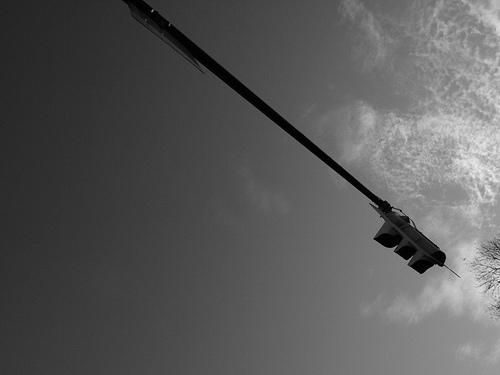Provide a brief description of the central object in the image and the overall atmosphere. A traffic light mounted on a pole is the central object, set in an outdoor cloudy daytime environment, captured in black and white. Explain the main focus of the image, including any significant details or accessories. The image primarily features a traffic light system and its pole, with noticeable details such as electrical wires and a sign attached to the pole. Mention the primary object of the image and its surrounding environment. A traffic light system is the central focus, accompanied by a tree with bare branches, clouds in the sky, and a street sign on a pole. Provide a concise description of the overall scene in the image. The scene comprises a traffic light and pole, a tree with bare branches, a sign on the pole, and white cloud formations against the sky. Highlight the most noticeable object in the image and mention its surroundings. A stoplight stands out in the image, with a tree without leaves on the right side and a mix of clear skies and white clouds in the background. Mention the standout element in the image and describe the secondary components in the scene. The image prominently features a traffic light, with accompanying elements such as bare tree branches, sign on the pole, and clouds in the sky. Provide a brief summary of the main elements in the image. The image features a stoplight on a pole, a tree without leaves, a sign attached to the pole, electrical wires, and clouds in the sky. Describe the primary subject in the picture, focusing on its surroundings. The picture showcases a traffic light on a pole, accompanied by a tree without leaves, part cloudy sky, and a sign attached to the pole. Describe the primary object and the atmospheric conditions in the image. A traffic light system is the main object, set against a backdrop of partly cloudy skies in a black and white photograph. Explain the key focal point of the image and its primary details. The prominent focus is a traffic light, with three round lights surrounded by metal and wires, mounted on a black pole with an attached sign. Is the sign on the pole an advertisement for a product? This instruction is misleading because it suggests that the sign on the pole is an advertisement, while it is actually a street sign. Notice how the sky is completely clear with no clouds in sight. The instruction is misleading because there are clouds in the sky, and they are a significant feature in the image. There are multiple stoplights in this photo, can you count them? This instruction is misleading because there is only one stoplight in the photo. Observe the vibrant colors in this photo of a traffic light. This instruction is misleading because it implies that the photo is in color, while it is actually a black and white photo. The traffic light pole is white in color, isn't it? The instruction is misleading because it suggests that the traffic light pole is white, while it is actually black. The clouds form a perfect circle, do you see that? This instruction is misleading because it suggests that the clouds form a circle, while they actually have a lacy pattern. The traffic light is mounted vertically on the pole, right? The instruction is misleading because it implies that the traffic light is mounted vertically, while it is actually angled. Do the electrical wires wrap around the pole in a spiral pattern? This instruction is misleading because it suggests that the wires create a spiral pattern around the pole, while they are actually located on the back of the pole. Does the tree on the right side of the photo have lots of green leaves? The instruction is misleading because it contradicts the correct information, which is that the tree is without any leaves. Are the protrusions on the end of the pole decorative elements? The instruction is misleading because it suggests that the protrusions are decorative, while they are actually functional components of the traffic light system. 